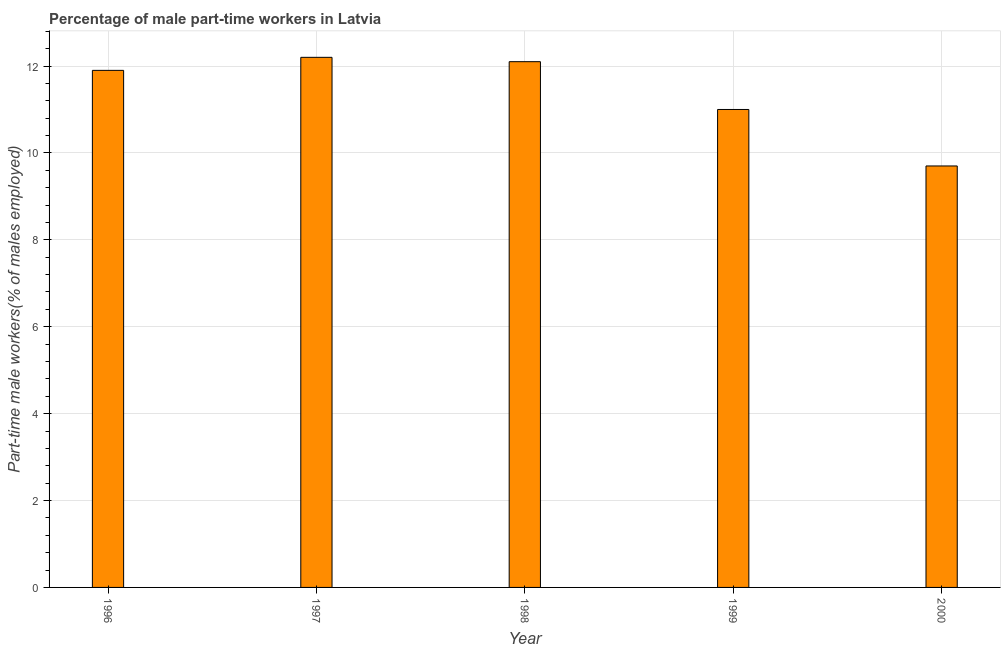What is the title of the graph?
Keep it short and to the point. Percentage of male part-time workers in Latvia. What is the label or title of the X-axis?
Your answer should be compact. Year. What is the label or title of the Y-axis?
Provide a short and direct response. Part-time male workers(% of males employed). What is the percentage of part-time male workers in 1999?
Offer a very short reply. 11. Across all years, what is the maximum percentage of part-time male workers?
Offer a terse response. 12.2. Across all years, what is the minimum percentage of part-time male workers?
Provide a succinct answer. 9.7. In which year was the percentage of part-time male workers minimum?
Offer a very short reply. 2000. What is the sum of the percentage of part-time male workers?
Provide a short and direct response. 56.9. What is the average percentage of part-time male workers per year?
Offer a terse response. 11.38. What is the median percentage of part-time male workers?
Give a very brief answer. 11.9. Do a majority of the years between 1998 and 1996 (inclusive) have percentage of part-time male workers greater than 3.2 %?
Your answer should be very brief. Yes. What is the ratio of the percentage of part-time male workers in 1996 to that in 2000?
Ensure brevity in your answer.  1.23. Is the difference between the percentage of part-time male workers in 1997 and 2000 greater than the difference between any two years?
Your response must be concise. Yes. Are all the bars in the graph horizontal?
Ensure brevity in your answer.  No. How many years are there in the graph?
Ensure brevity in your answer.  5. Are the values on the major ticks of Y-axis written in scientific E-notation?
Your answer should be very brief. No. What is the Part-time male workers(% of males employed) in 1996?
Offer a very short reply. 11.9. What is the Part-time male workers(% of males employed) of 1997?
Ensure brevity in your answer.  12.2. What is the Part-time male workers(% of males employed) in 1998?
Offer a terse response. 12.1. What is the Part-time male workers(% of males employed) in 1999?
Provide a short and direct response. 11. What is the Part-time male workers(% of males employed) in 2000?
Ensure brevity in your answer.  9.7. What is the difference between the Part-time male workers(% of males employed) in 1996 and 1999?
Your answer should be very brief. 0.9. What is the difference between the Part-time male workers(% of males employed) in 1997 and 1998?
Offer a terse response. 0.1. What is the difference between the Part-time male workers(% of males employed) in 1997 and 1999?
Make the answer very short. 1.2. What is the difference between the Part-time male workers(% of males employed) in 1997 and 2000?
Ensure brevity in your answer.  2.5. What is the difference between the Part-time male workers(% of males employed) in 1998 and 2000?
Ensure brevity in your answer.  2.4. What is the ratio of the Part-time male workers(% of males employed) in 1996 to that in 1998?
Give a very brief answer. 0.98. What is the ratio of the Part-time male workers(% of males employed) in 1996 to that in 1999?
Your answer should be compact. 1.08. What is the ratio of the Part-time male workers(% of males employed) in 1996 to that in 2000?
Make the answer very short. 1.23. What is the ratio of the Part-time male workers(% of males employed) in 1997 to that in 1999?
Make the answer very short. 1.11. What is the ratio of the Part-time male workers(% of males employed) in 1997 to that in 2000?
Your response must be concise. 1.26. What is the ratio of the Part-time male workers(% of males employed) in 1998 to that in 1999?
Your answer should be very brief. 1.1. What is the ratio of the Part-time male workers(% of males employed) in 1998 to that in 2000?
Offer a very short reply. 1.25. What is the ratio of the Part-time male workers(% of males employed) in 1999 to that in 2000?
Provide a short and direct response. 1.13. 